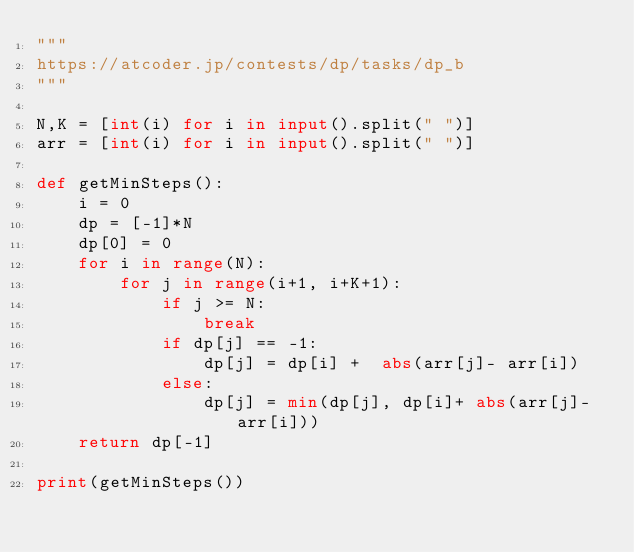<code> <loc_0><loc_0><loc_500><loc_500><_Python_>"""
https://atcoder.jp/contests/dp/tasks/dp_b
"""
 
N,K = [int(i) for i in input().split(" ")]
arr = [int(i) for i in input().split(" ")]
 
def getMinSteps():
    i = 0
    dp = [-1]*N
    dp[0] = 0
    for i in range(N):
        for j in range(i+1, i+K+1):
            if j >= N:
                break
            if dp[j] == -1:
                dp[j] = dp[i] +  abs(arr[j]- arr[i])
            else:
                dp[j] = min(dp[j], dp[i]+ abs(arr[j]- arr[i]))
    return dp[-1]
        
print(getMinSteps())</code> 